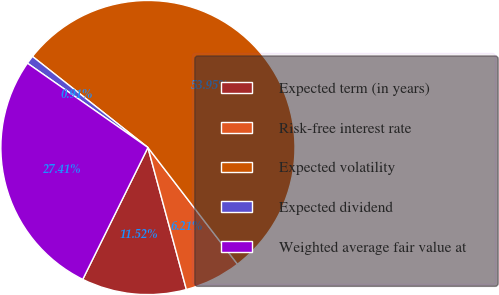Convert chart. <chart><loc_0><loc_0><loc_500><loc_500><pie_chart><fcel>Expected term (in years)<fcel>Risk-free interest rate<fcel>Expected volatility<fcel>Expected dividend<fcel>Weighted average fair value at<nl><fcel>11.52%<fcel>6.21%<fcel>53.95%<fcel>0.91%<fcel>27.41%<nl></chart> 